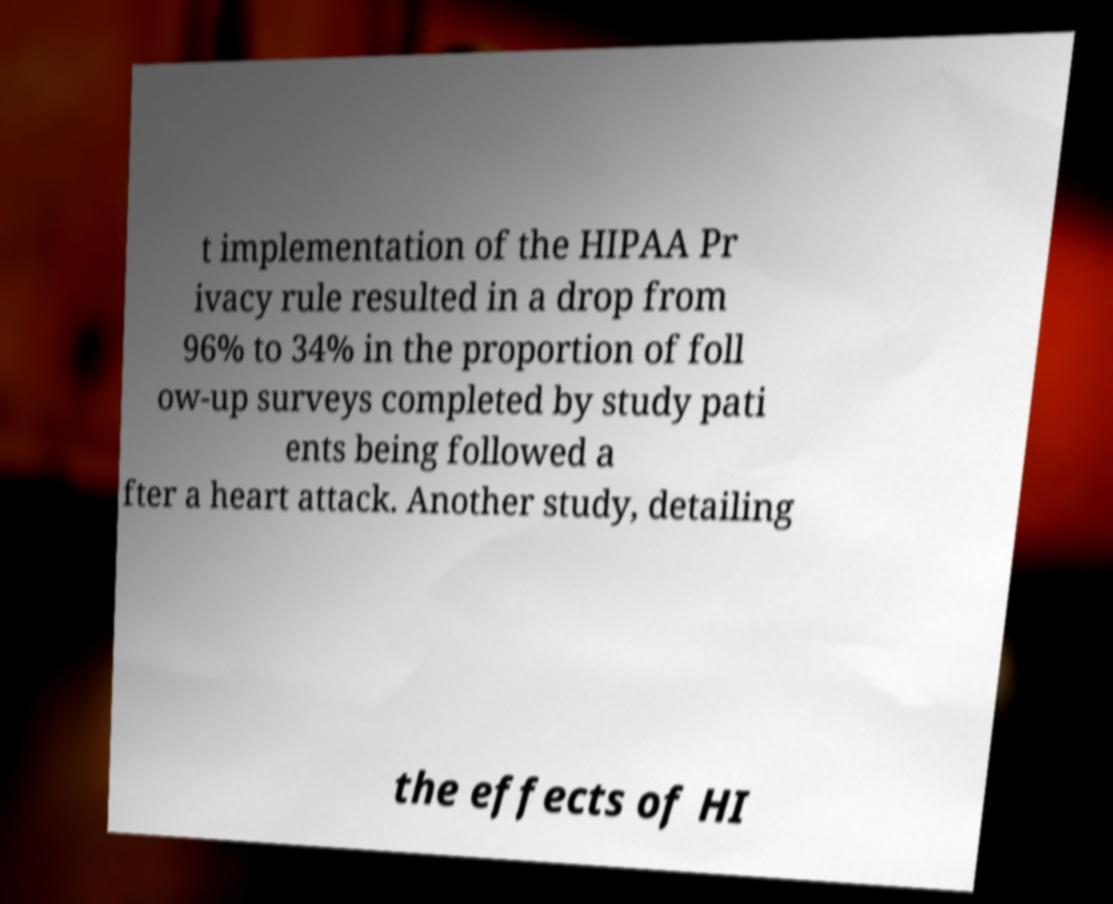What messages or text are displayed in this image? I need them in a readable, typed format. t implementation of the HIPAA Pr ivacy rule resulted in a drop from 96% to 34% in the proportion of foll ow-up surveys completed by study pati ents being followed a fter a heart attack. Another study, detailing the effects of HI 